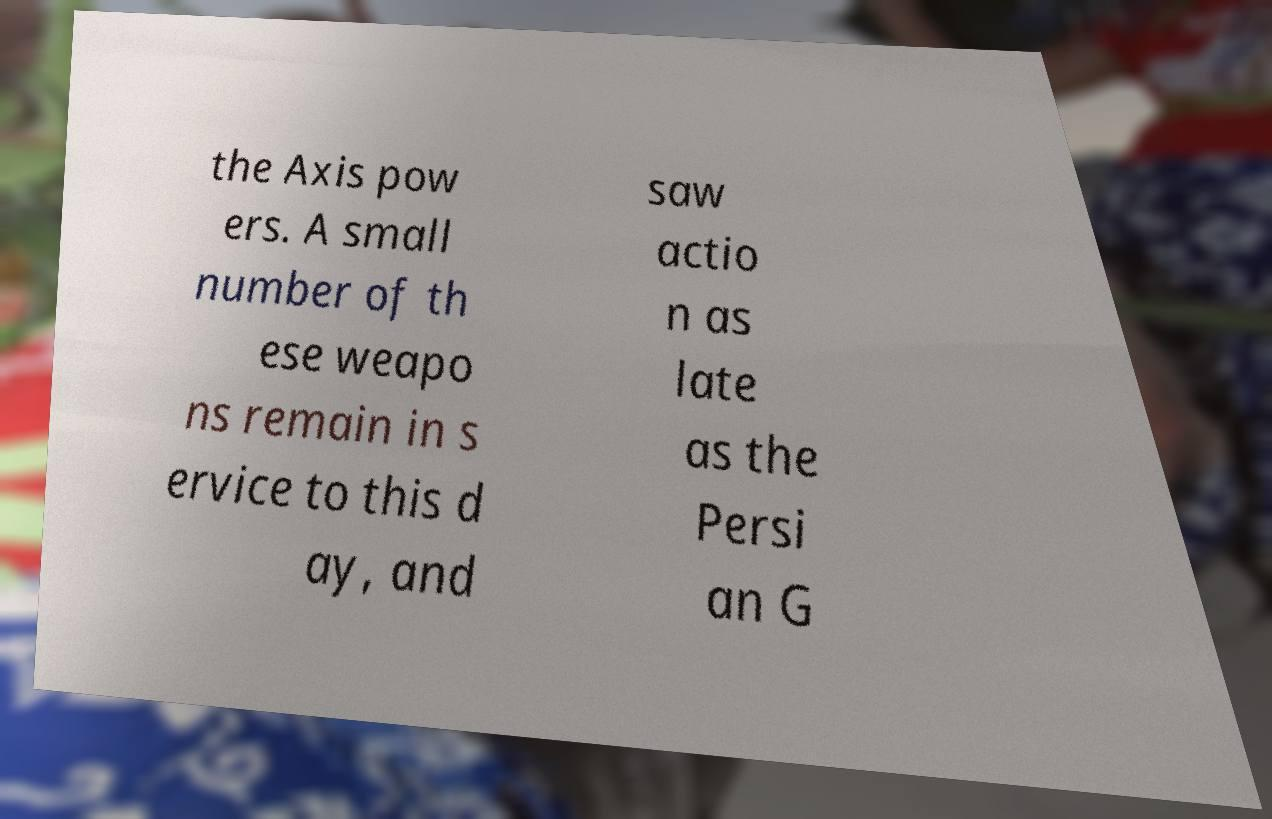Please read and relay the text visible in this image. What does it say? the Axis pow ers. A small number of th ese weapo ns remain in s ervice to this d ay, and saw actio n as late as the Persi an G 